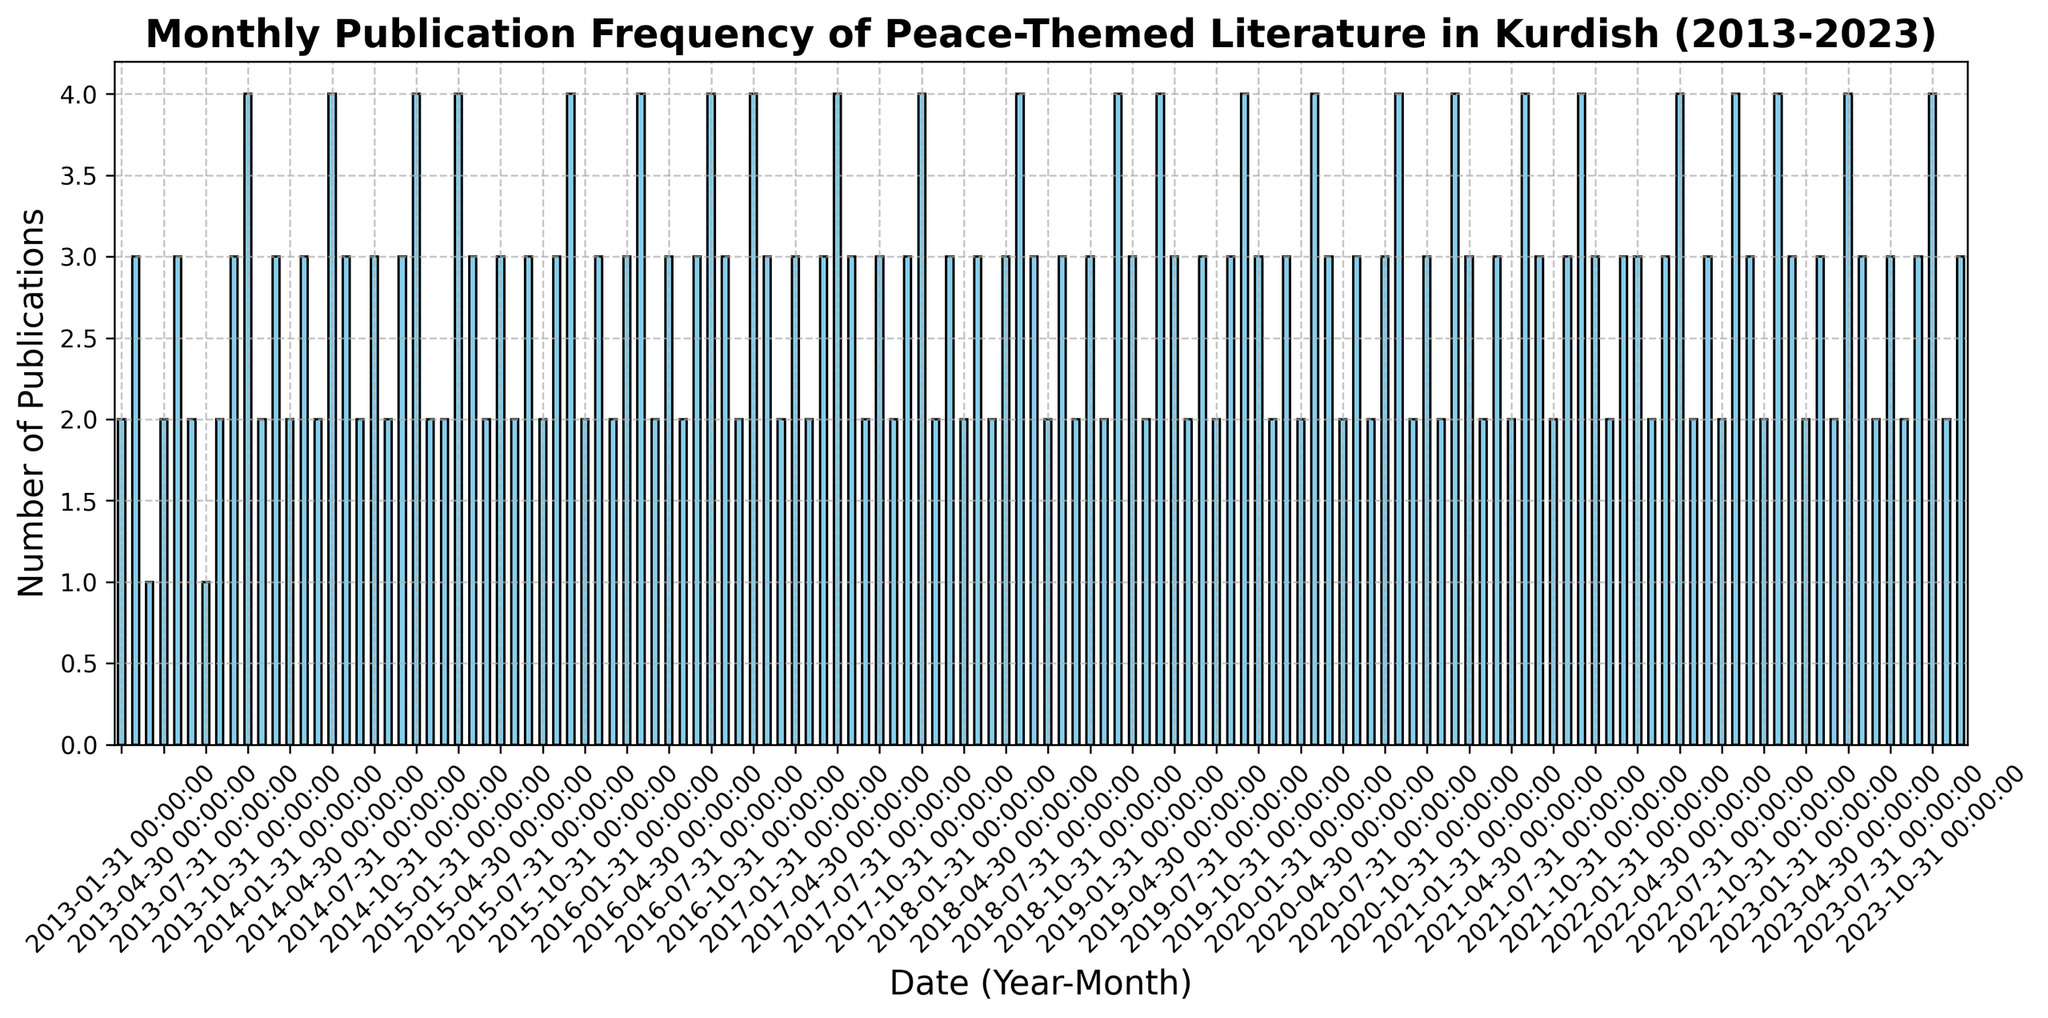What is the most frequently occurring monthly publication count? To find the most frequently occurring monthly publication count, look at the heights of the bars and count the number of months where each bar height recurs. From the histogram, we observe that the publication count of 3 appears most frequently.
Answer: 3 Which month had the highest publication count over the entire decade? The month with the highest publication count is represented by the tallest bar in the histogram. By visually inspecting, we can see that the bars for April 2023 and November 2022 (and a few other months) are the tallest, each with a publication count of 4.
Answer: April 2023 and November 2022 How often does the monthly publication count reach the maximum value? To determine this, count the bars that reach the maximum height of 4. By inspecting the histogram, we count 18 bars with the height of 4 throughout the decade.
Answer: 18 times Compare the publication counts of January 2013 and January 2022. Which one is higher? To compare, find the heights of the bars corresponding to January 2013 and January 2022. For January 2013, the publication count is 2, and for January 2022, it is 3.
Answer: January 2022 is higher What is the average monthly publication count for the year 2013? Sum the publication counts for each month in 2013 and divide by 12. The counts are [2, 3, 1, 2, 3, 2, 1, 2, 3, 4, 2, 3]. The total is 28, and the average is 28/12 = 2.33.
Answer: 2.33 During which year did the monthly publication count most frequently reach four? To determine this, we need to count the number of times a publication count of 4 appears each year. By checking the histogram, the year with the most 4's is 2022 with 3 occurrences of a publication count of 4.
Answer: 2022 Is the publication trend increasing, decreasing, or stable over the decade? Observing the general heights of bars from left (2013) to right (2023), we can determine the trend. While there are fluctuations, the heights of bars do not show a clear upward or downward trend, suggesting the publication frequency has remained relatively stable.
Answer: Stable Which month of any year has the lowest publication count, and what is that count? The lowest publication count is represented by the shortest bar in the histogram. Visually inspecting, we find January 2013 and March 2013 each have the lowest count of 1 publication.
Answer: January 2013 and March 2013, count of 1 